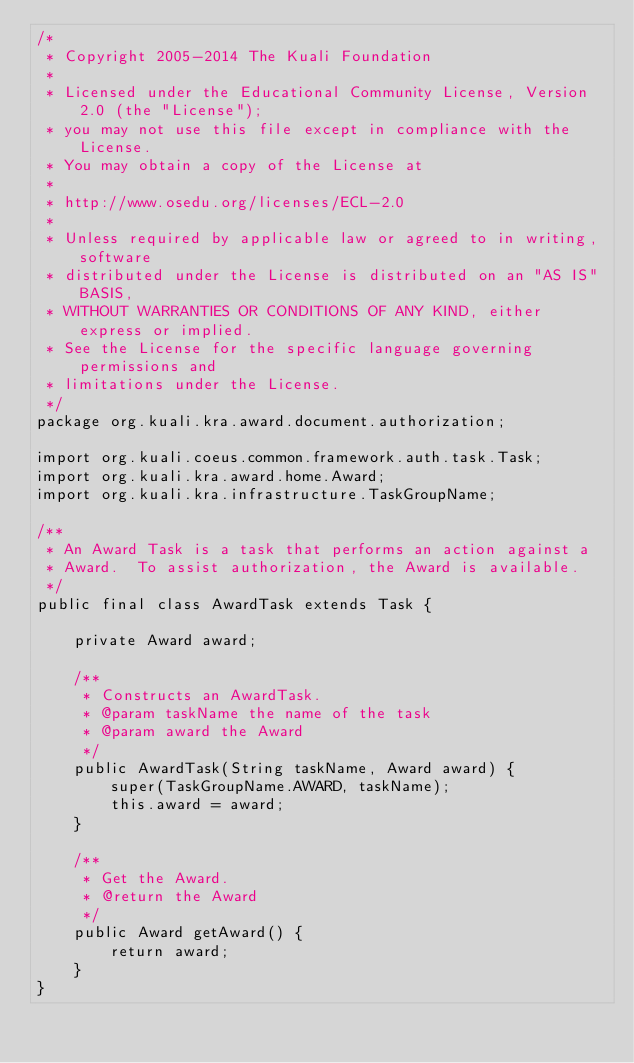<code> <loc_0><loc_0><loc_500><loc_500><_Java_>/*
 * Copyright 2005-2014 The Kuali Foundation
 * 
 * Licensed under the Educational Community License, Version 2.0 (the "License");
 * you may not use this file except in compliance with the License.
 * You may obtain a copy of the License at
 * 
 * http://www.osedu.org/licenses/ECL-2.0
 * 
 * Unless required by applicable law or agreed to in writing, software
 * distributed under the License is distributed on an "AS IS" BASIS,
 * WITHOUT WARRANTIES OR CONDITIONS OF ANY KIND, either express or implied.
 * See the License for the specific language governing permissions and
 * limitations under the License.
 */
package org.kuali.kra.award.document.authorization;

import org.kuali.coeus.common.framework.auth.task.Task;
import org.kuali.kra.award.home.Award;
import org.kuali.kra.infrastructure.TaskGroupName;

/**
 * An Award Task is a task that performs an action against a
 * Award.  To assist authorization, the Award is available.
 */
public final class AwardTask extends Task {
    
    private Award award;
    
    /**
     * Constructs an AwardTask.
     * @param taskName the name of the task
     * @param award the Award
     */
    public AwardTask(String taskName, Award award) {
        super(TaskGroupName.AWARD, taskName);
        this.award = award;
    }

    /**
     * Get the Award.
     * @return the Award
     */
    public Award getAward() {
        return award;
    }
}
</code> 